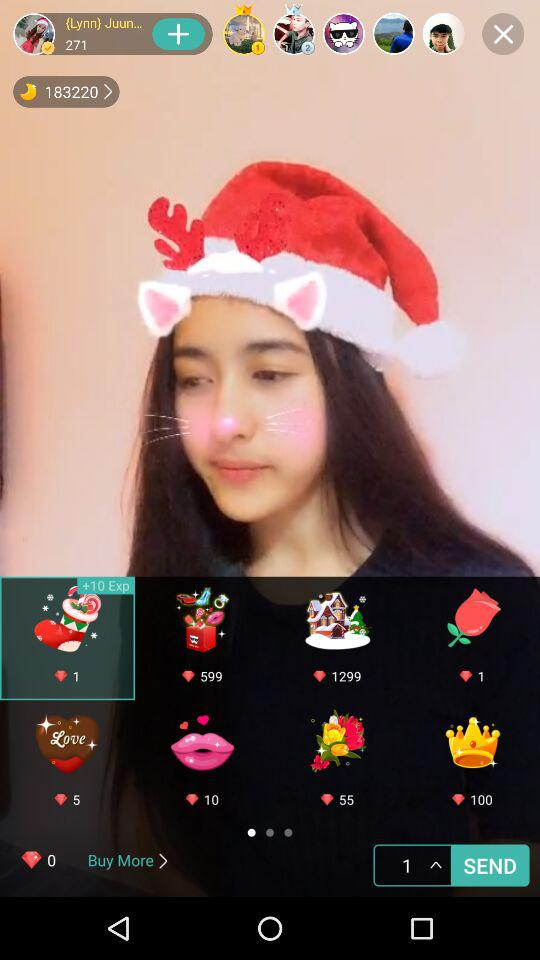How many diamonds are required to buy the selected icon? There is one diamond required. 